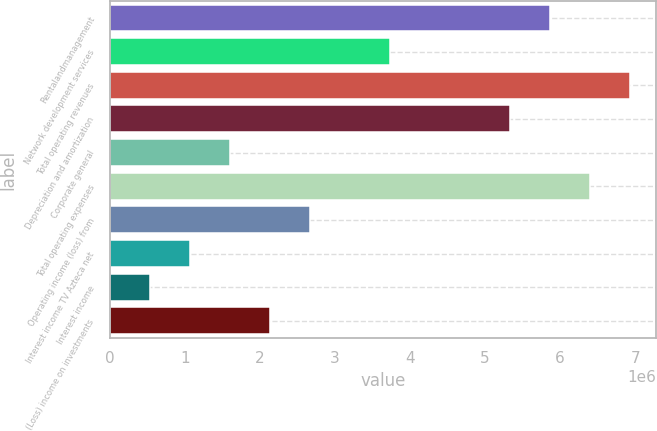Convert chart. <chart><loc_0><loc_0><loc_500><loc_500><bar_chart><fcel>Rentalandmanagement<fcel>Network development services<fcel>Total operating revenues<fcel>Depreciation and amortization<fcel>Corporate general<fcel>Total operating expenses<fcel>Operating income (loss) from<fcel>Interest income TV Azteca net<fcel>Interest income<fcel>(Loss) income on investments<nl><fcel>5.86537e+06<fcel>3.73385e+06<fcel>6.93112e+06<fcel>5.33249e+06<fcel>1.60234e+06<fcel>6.39824e+06<fcel>2.6681e+06<fcel>1.06946e+06<fcel>536582<fcel>2.13522e+06<nl></chart> 